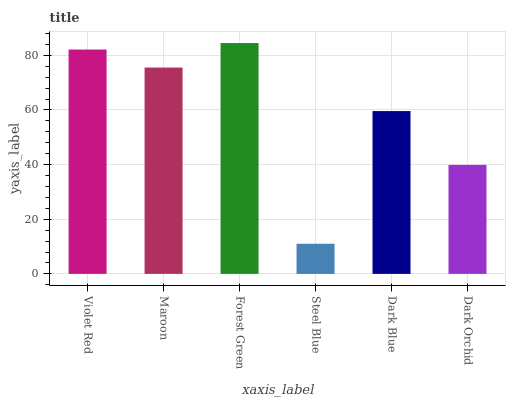Is Steel Blue the minimum?
Answer yes or no. Yes. Is Forest Green the maximum?
Answer yes or no. Yes. Is Maroon the minimum?
Answer yes or no. No. Is Maroon the maximum?
Answer yes or no. No. Is Violet Red greater than Maroon?
Answer yes or no. Yes. Is Maroon less than Violet Red?
Answer yes or no. Yes. Is Maroon greater than Violet Red?
Answer yes or no. No. Is Violet Red less than Maroon?
Answer yes or no. No. Is Maroon the high median?
Answer yes or no. Yes. Is Dark Blue the low median?
Answer yes or no. Yes. Is Violet Red the high median?
Answer yes or no. No. Is Maroon the low median?
Answer yes or no. No. 